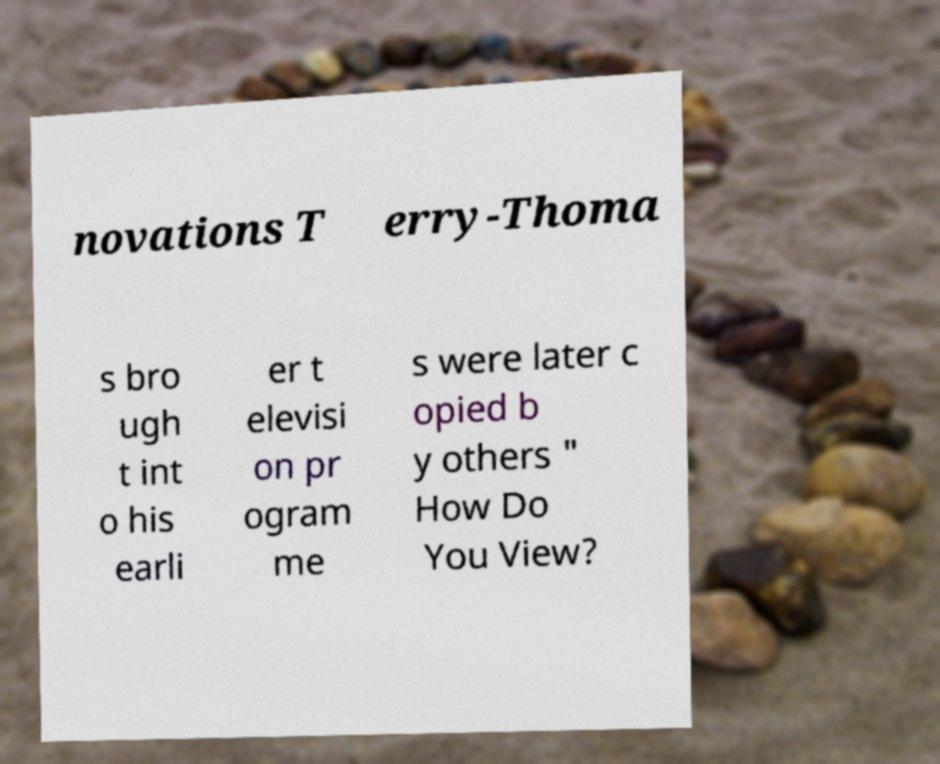Please read and relay the text visible in this image. What does it say? novations T erry-Thoma s bro ugh t int o his earli er t elevisi on pr ogram me s were later c opied b y others " How Do You View? 